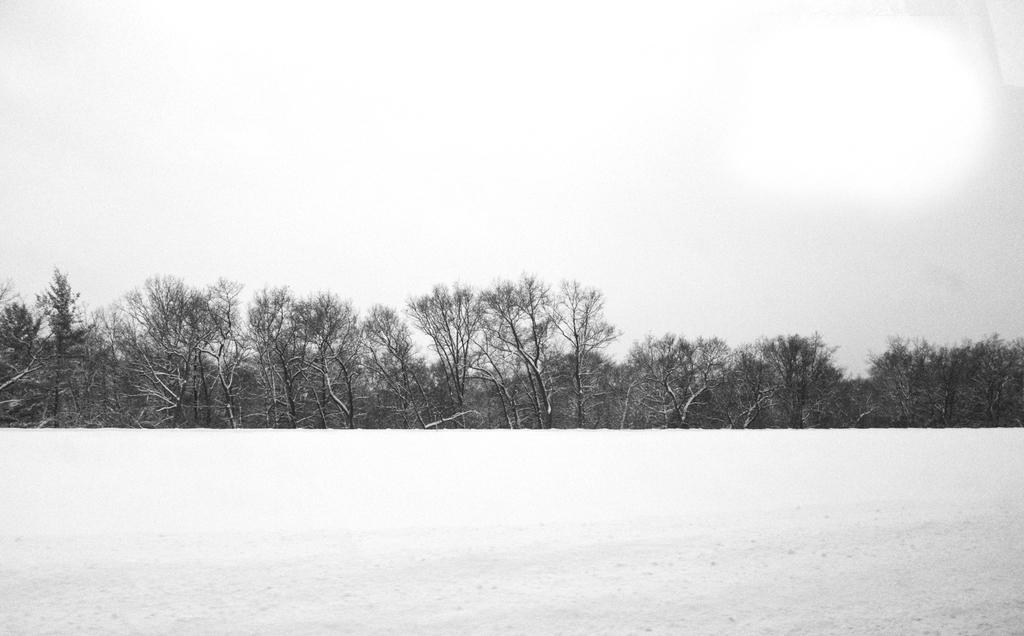Can you describe this image briefly? In this picture we can see snow, trees and in the background we can see the sky. 